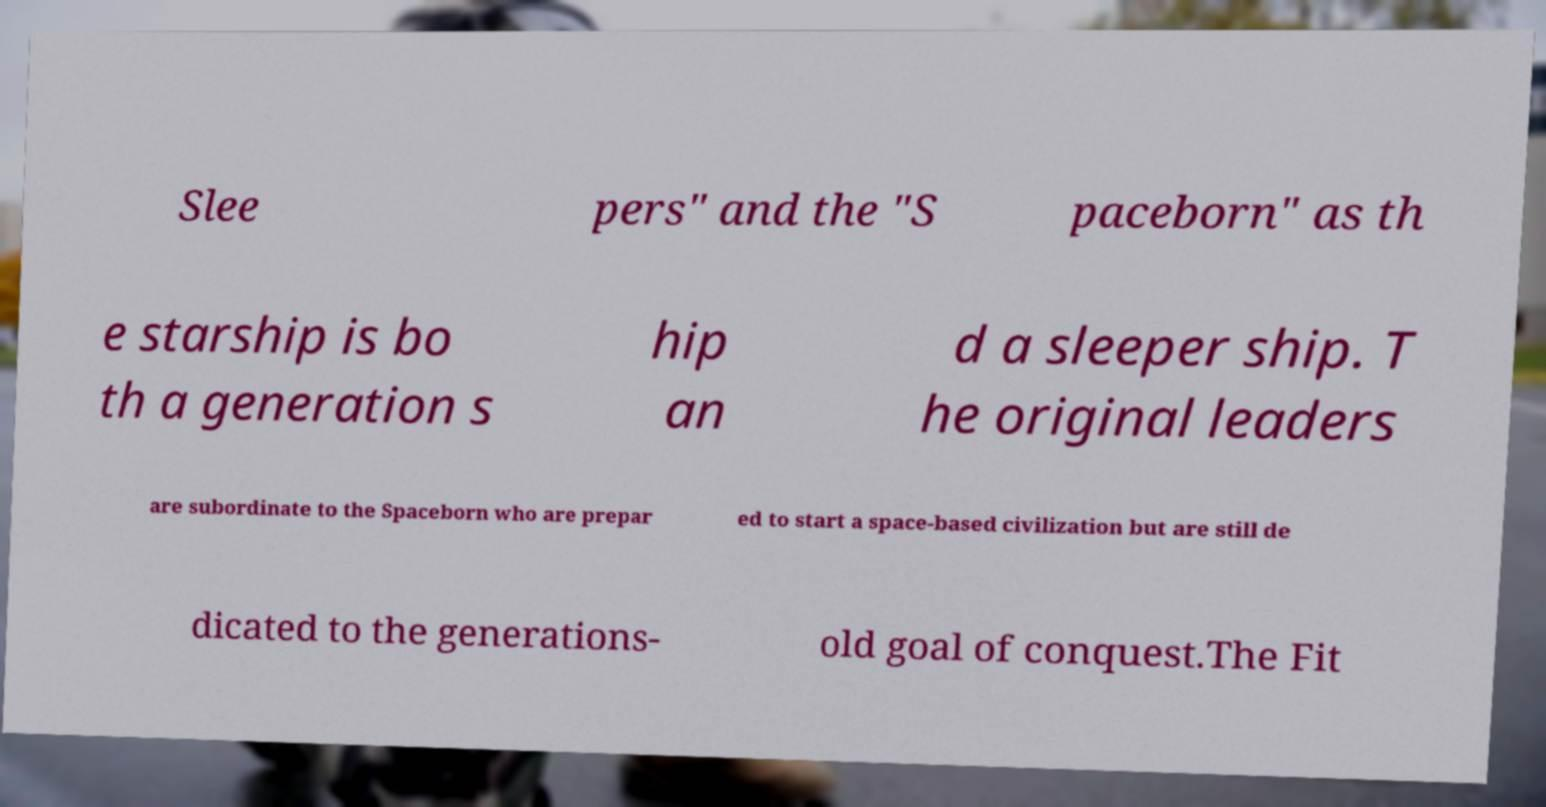Please identify and transcribe the text found in this image. Slee pers" and the "S paceborn" as th e starship is bo th a generation s hip an d a sleeper ship. T he original leaders are subordinate to the Spaceborn who are prepar ed to start a space-based civilization but are still de dicated to the generations- old goal of conquest.The Fit 